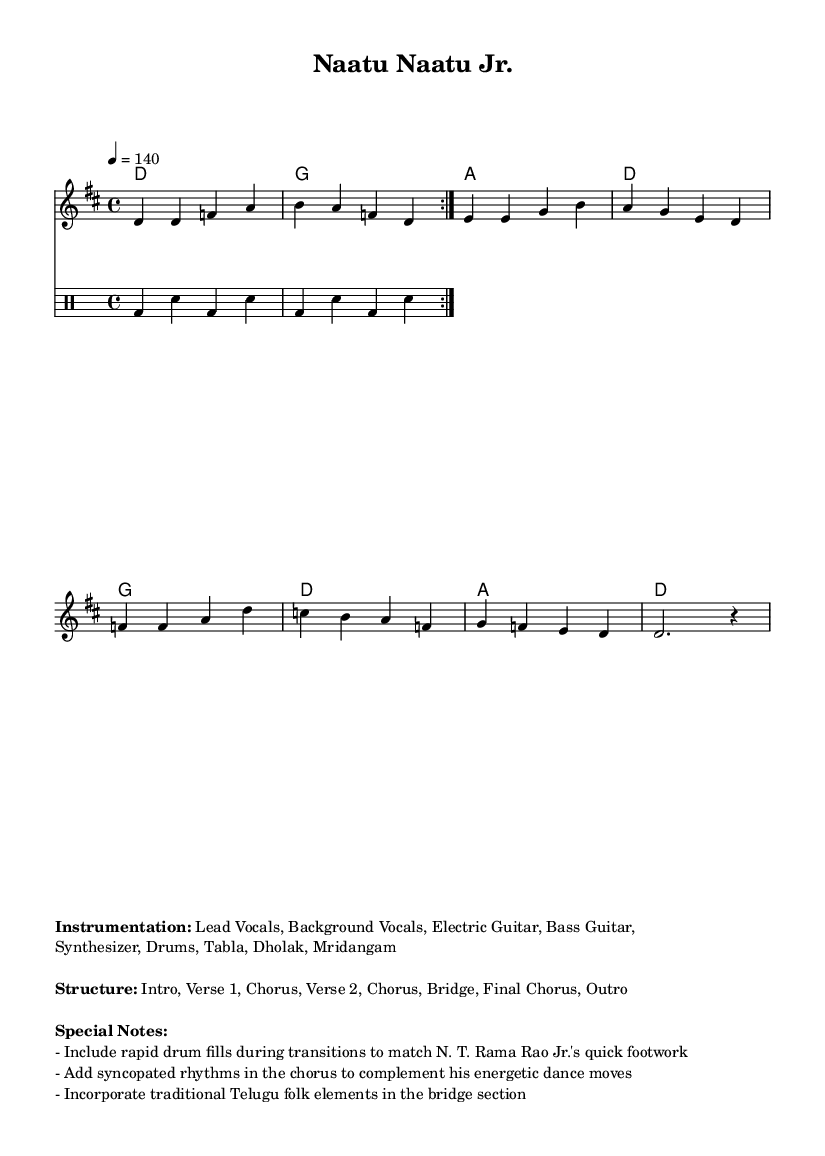What is the key signature of this music? The key signature is D major, which is indicated at the beginning of the score with two sharps.
Answer: D major What is the time signature of this music? The time signature is located at the beginning of the score, after the key signature, and is set to 4/4.
Answer: 4/4 What is the tempo marking of this music? The tempo marking appears at the start and is indicated as quarter note equals 140 beats per minute, guiding the performance speed.
Answer: 140 How many measures are present in the melody section? The melody section has 8 measures, which can be counted from the beginning to the end of the melodic line.
Answer: 8 measures What special notes suggest changes to match N. T. Rama Rao Jr.'s dance moves? The special notes mention rapid drum fills during transitions and syncopated rhythms in the chorus to complement the energetic dance moves.
Answer: Rapid drum fills, syncopated rhythms What instrumentation is listed for this piece? The instrumentation is provided in the markup section and includes several instruments like Lead Vocals, Electric Guitar, Drums, and more.
Answer: Lead Vocals, Electric Guitar, Drums, Tabla, Dholak, Mridangam What type of musical elements are incorporated in the bridge section? The special notes specify that the bridge should include traditional Telugu folk elements, adding unique cultural flavor to the song.
Answer: Traditional Telugu folk elements 